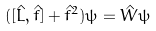Convert formula to latex. <formula><loc_0><loc_0><loc_500><loc_500>( [ \hat { L } , \hat { f } ] + { \hat { f } } ^ { 2 } ) \psi = \hat { W } \psi</formula> 